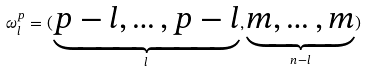Convert formula to latex. <formula><loc_0><loc_0><loc_500><loc_500>\omega ^ { p } _ { l } = ( \underbrace { p - l , \dots , p - l } _ { l } , \underbrace { m , \dots , m } _ { n - l } )</formula> 